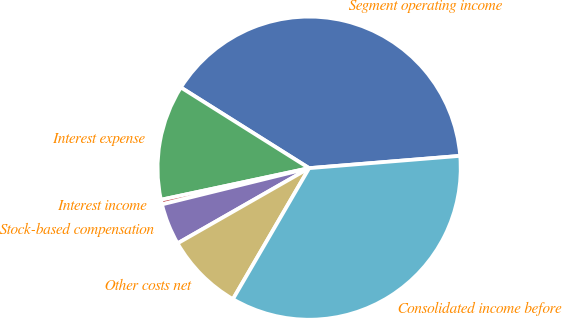Convert chart. <chart><loc_0><loc_0><loc_500><loc_500><pie_chart><fcel>Segment operating income<fcel>Interest expense<fcel>Interest income<fcel>Stock-based compensation<fcel>Other costs net<fcel>Consolidated income before<nl><fcel>39.77%<fcel>12.28%<fcel>0.5%<fcel>4.42%<fcel>8.35%<fcel>34.68%<nl></chart> 